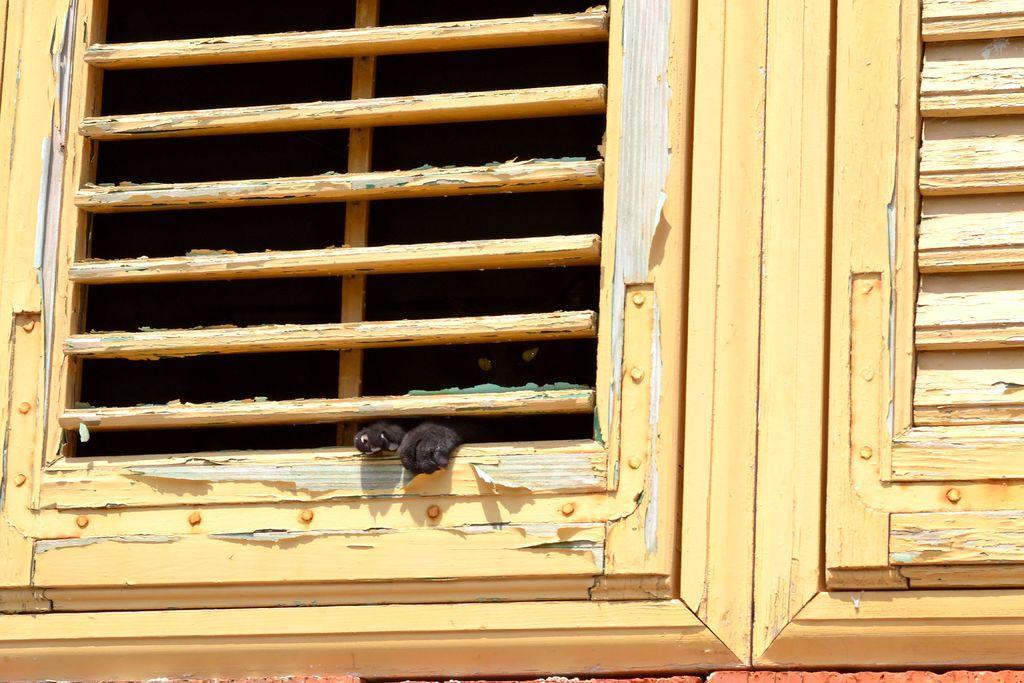Could you give a brief overview of what you see in this image? In this image, we can see wooden windows and there is an animal standing at the window. 